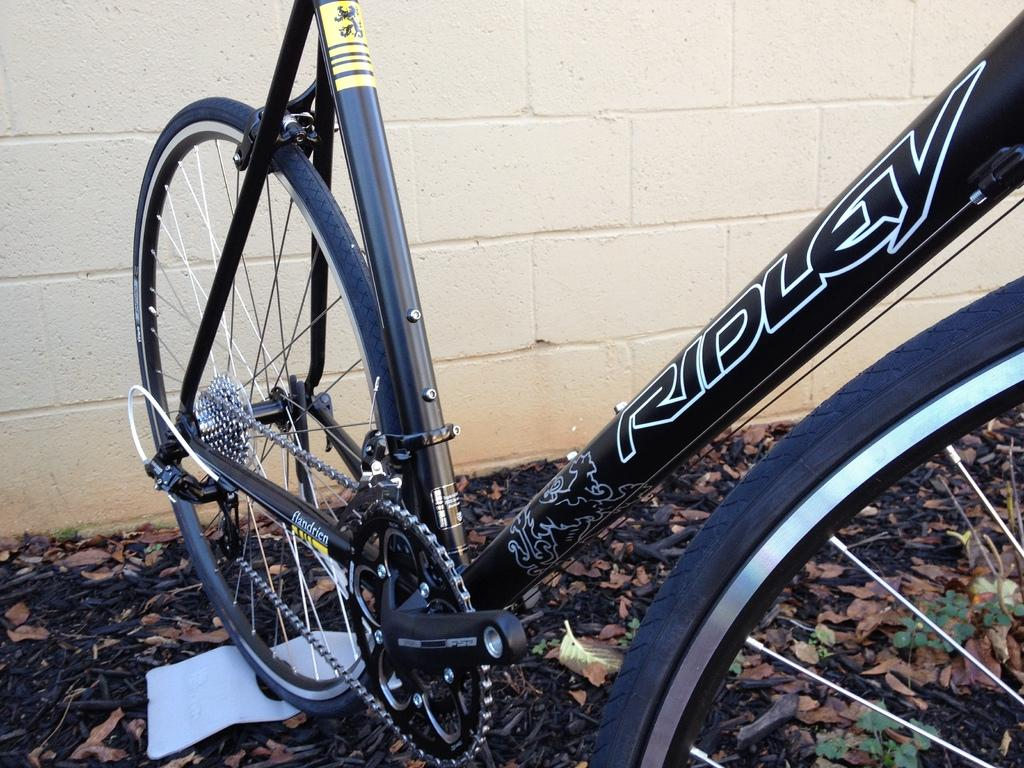What is the main subject in the center of the image? There is a bicycle in the center of the image. Can you describe the position of the bicycle in the image? The bicycle is on the ground. What can be seen in the background of the image? There is a wall in the background of the image. What type of bread can be seen hanging from the wall in the image? There is no bread present in the image, and therefore no such activity can be observed. 